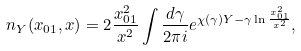<formula> <loc_0><loc_0><loc_500><loc_500>n _ { Y } ( x _ { 0 1 } , x ) = 2 \frac { x _ { 0 1 } ^ { 2 } } { x ^ { 2 } } \int \frac { d \gamma } { 2 \pi i } e ^ { \chi ( \gamma ) Y - \gamma \ln \frac { x _ { 0 1 } ^ { 2 } } { x ^ { 2 } } } ,</formula> 